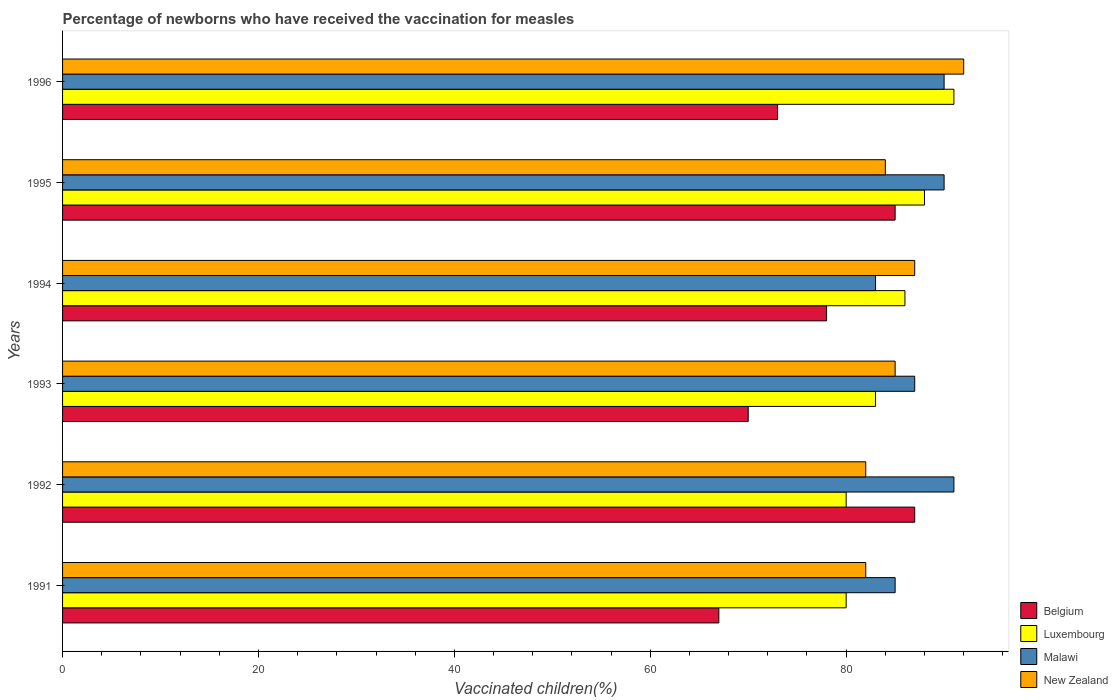How many different coloured bars are there?
Your response must be concise. 4. How many groups of bars are there?
Offer a terse response. 6. Are the number of bars on each tick of the Y-axis equal?
Ensure brevity in your answer.  Yes. How many bars are there on the 2nd tick from the top?
Ensure brevity in your answer.  4. How many bars are there on the 3rd tick from the bottom?
Provide a short and direct response. 4. What is the percentage of vaccinated children in New Zealand in 1991?
Provide a succinct answer. 82. Across all years, what is the maximum percentage of vaccinated children in Luxembourg?
Your answer should be compact. 91. Across all years, what is the minimum percentage of vaccinated children in New Zealand?
Ensure brevity in your answer.  82. In which year was the percentage of vaccinated children in Malawi maximum?
Offer a very short reply. 1992. What is the total percentage of vaccinated children in Luxembourg in the graph?
Provide a short and direct response. 508. What is the average percentage of vaccinated children in Belgium per year?
Provide a succinct answer. 76.67. In the year 1994, what is the difference between the percentage of vaccinated children in Belgium and percentage of vaccinated children in Luxembourg?
Provide a short and direct response. -8. What is the ratio of the percentage of vaccinated children in Luxembourg in 1992 to that in 1996?
Your answer should be compact. 0.88. What is the difference between the highest and the lowest percentage of vaccinated children in Malawi?
Provide a succinct answer. 8. What does the 4th bar from the bottom in 1995 represents?
Offer a terse response. New Zealand. How many bars are there?
Your answer should be very brief. 24. What is the difference between two consecutive major ticks on the X-axis?
Ensure brevity in your answer.  20. Does the graph contain grids?
Make the answer very short. No. Where does the legend appear in the graph?
Make the answer very short. Bottom right. How many legend labels are there?
Your answer should be compact. 4. How are the legend labels stacked?
Provide a short and direct response. Vertical. What is the title of the graph?
Make the answer very short. Percentage of newborns who have received the vaccination for measles. What is the label or title of the X-axis?
Offer a very short reply. Vaccinated children(%). What is the label or title of the Y-axis?
Ensure brevity in your answer.  Years. What is the Vaccinated children(%) in Belgium in 1991?
Make the answer very short. 67. What is the Vaccinated children(%) in Luxembourg in 1991?
Your answer should be very brief. 80. What is the Vaccinated children(%) in New Zealand in 1991?
Your answer should be very brief. 82. What is the Vaccinated children(%) in Belgium in 1992?
Make the answer very short. 87. What is the Vaccinated children(%) of Malawi in 1992?
Keep it short and to the point. 91. What is the Vaccinated children(%) of Belgium in 1993?
Provide a short and direct response. 70. What is the Vaccinated children(%) in Malawi in 1993?
Ensure brevity in your answer.  87. What is the Vaccinated children(%) in Belgium in 1995?
Your answer should be very brief. 85. What is the Vaccinated children(%) of New Zealand in 1995?
Your answer should be very brief. 84. What is the Vaccinated children(%) of Luxembourg in 1996?
Your answer should be compact. 91. What is the Vaccinated children(%) in Malawi in 1996?
Give a very brief answer. 90. What is the Vaccinated children(%) in New Zealand in 1996?
Ensure brevity in your answer.  92. Across all years, what is the maximum Vaccinated children(%) in Belgium?
Give a very brief answer. 87. Across all years, what is the maximum Vaccinated children(%) in Luxembourg?
Ensure brevity in your answer.  91. Across all years, what is the maximum Vaccinated children(%) of Malawi?
Offer a very short reply. 91. Across all years, what is the maximum Vaccinated children(%) in New Zealand?
Provide a short and direct response. 92. Across all years, what is the minimum Vaccinated children(%) in Belgium?
Offer a very short reply. 67. Across all years, what is the minimum Vaccinated children(%) in Luxembourg?
Offer a very short reply. 80. Across all years, what is the minimum Vaccinated children(%) of New Zealand?
Make the answer very short. 82. What is the total Vaccinated children(%) of Belgium in the graph?
Make the answer very short. 460. What is the total Vaccinated children(%) of Luxembourg in the graph?
Provide a short and direct response. 508. What is the total Vaccinated children(%) in Malawi in the graph?
Give a very brief answer. 526. What is the total Vaccinated children(%) of New Zealand in the graph?
Your answer should be very brief. 512. What is the difference between the Vaccinated children(%) of Belgium in 1991 and that in 1992?
Provide a succinct answer. -20. What is the difference between the Vaccinated children(%) of Malawi in 1991 and that in 1992?
Offer a terse response. -6. What is the difference between the Vaccinated children(%) of New Zealand in 1991 and that in 1992?
Your answer should be compact. 0. What is the difference between the Vaccinated children(%) of Belgium in 1991 and that in 1993?
Provide a succinct answer. -3. What is the difference between the Vaccinated children(%) of Malawi in 1991 and that in 1993?
Your answer should be compact. -2. What is the difference between the Vaccinated children(%) of Luxembourg in 1991 and that in 1994?
Provide a succinct answer. -6. What is the difference between the Vaccinated children(%) of Malawi in 1991 and that in 1994?
Your response must be concise. 2. What is the difference between the Vaccinated children(%) in New Zealand in 1991 and that in 1994?
Ensure brevity in your answer.  -5. What is the difference between the Vaccinated children(%) of Belgium in 1991 and that in 1995?
Ensure brevity in your answer.  -18. What is the difference between the Vaccinated children(%) in Luxembourg in 1991 and that in 1995?
Provide a short and direct response. -8. What is the difference between the Vaccinated children(%) in Malawi in 1991 and that in 1995?
Provide a short and direct response. -5. What is the difference between the Vaccinated children(%) in Belgium in 1991 and that in 1996?
Provide a short and direct response. -6. What is the difference between the Vaccinated children(%) in Malawi in 1991 and that in 1996?
Your answer should be compact. -5. What is the difference between the Vaccinated children(%) of Luxembourg in 1992 and that in 1994?
Keep it short and to the point. -6. What is the difference between the Vaccinated children(%) of Malawi in 1992 and that in 1994?
Ensure brevity in your answer.  8. What is the difference between the Vaccinated children(%) in Belgium in 1992 and that in 1995?
Your response must be concise. 2. What is the difference between the Vaccinated children(%) in Malawi in 1992 and that in 1996?
Provide a short and direct response. 1. What is the difference between the Vaccinated children(%) in New Zealand in 1992 and that in 1996?
Provide a short and direct response. -10. What is the difference between the Vaccinated children(%) of Luxembourg in 1993 and that in 1994?
Provide a succinct answer. -3. What is the difference between the Vaccinated children(%) of Malawi in 1993 and that in 1994?
Make the answer very short. 4. What is the difference between the Vaccinated children(%) in Belgium in 1993 and that in 1995?
Make the answer very short. -15. What is the difference between the Vaccinated children(%) of New Zealand in 1993 and that in 1995?
Offer a terse response. 1. What is the difference between the Vaccinated children(%) of Luxembourg in 1993 and that in 1996?
Give a very brief answer. -8. What is the difference between the Vaccinated children(%) of Malawi in 1993 and that in 1996?
Offer a very short reply. -3. What is the difference between the Vaccinated children(%) in Belgium in 1994 and that in 1996?
Make the answer very short. 5. What is the difference between the Vaccinated children(%) of Luxembourg in 1994 and that in 1996?
Offer a terse response. -5. What is the difference between the Vaccinated children(%) of Belgium in 1995 and that in 1996?
Make the answer very short. 12. What is the difference between the Vaccinated children(%) in Luxembourg in 1995 and that in 1996?
Your response must be concise. -3. What is the difference between the Vaccinated children(%) in Belgium in 1991 and the Vaccinated children(%) in Luxembourg in 1992?
Provide a succinct answer. -13. What is the difference between the Vaccinated children(%) in Belgium in 1991 and the Vaccinated children(%) in Malawi in 1992?
Offer a terse response. -24. What is the difference between the Vaccinated children(%) of Luxembourg in 1991 and the Vaccinated children(%) of Malawi in 1992?
Keep it short and to the point. -11. What is the difference between the Vaccinated children(%) of Luxembourg in 1991 and the Vaccinated children(%) of New Zealand in 1992?
Offer a terse response. -2. What is the difference between the Vaccinated children(%) in Belgium in 1991 and the Vaccinated children(%) in Malawi in 1993?
Give a very brief answer. -20. What is the difference between the Vaccinated children(%) of Belgium in 1991 and the Vaccinated children(%) of New Zealand in 1993?
Ensure brevity in your answer.  -18. What is the difference between the Vaccinated children(%) in Luxembourg in 1991 and the Vaccinated children(%) in Malawi in 1993?
Offer a very short reply. -7. What is the difference between the Vaccinated children(%) of Malawi in 1991 and the Vaccinated children(%) of New Zealand in 1993?
Ensure brevity in your answer.  0. What is the difference between the Vaccinated children(%) in Belgium in 1991 and the Vaccinated children(%) in Malawi in 1994?
Make the answer very short. -16. What is the difference between the Vaccinated children(%) of Belgium in 1991 and the Vaccinated children(%) of New Zealand in 1994?
Keep it short and to the point. -20. What is the difference between the Vaccinated children(%) in Malawi in 1991 and the Vaccinated children(%) in New Zealand in 1994?
Make the answer very short. -2. What is the difference between the Vaccinated children(%) of Belgium in 1991 and the Vaccinated children(%) of Luxembourg in 1995?
Give a very brief answer. -21. What is the difference between the Vaccinated children(%) of Luxembourg in 1991 and the Vaccinated children(%) of Malawi in 1995?
Offer a terse response. -10. What is the difference between the Vaccinated children(%) in Luxembourg in 1991 and the Vaccinated children(%) in New Zealand in 1995?
Your answer should be very brief. -4. What is the difference between the Vaccinated children(%) in Belgium in 1991 and the Vaccinated children(%) in Luxembourg in 1996?
Keep it short and to the point. -24. What is the difference between the Vaccinated children(%) of Belgium in 1991 and the Vaccinated children(%) of New Zealand in 1996?
Your answer should be compact. -25. What is the difference between the Vaccinated children(%) of Belgium in 1992 and the Vaccinated children(%) of New Zealand in 1993?
Offer a terse response. 2. What is the difference between the Vaccinated children(%) of Luxembourg in 1992 and the Vaccinated children(%) of Malawi in 1993?
Give a very brief answer. -7. What is the difference between the Vaccinated children(%) of Luxembourg in 1992 and the Vaccinated children(%) of New Zealand in 1993?
Give a very brief answer. -5. What is the difference between the Vaccinated children(%) of Malawi in 1992 and the Vaccinated children(%) of New Zealand in 1993?
Your answer should be very brief. 6. What is the difference between the Vaccinated children(%) in Luxembourg in 1992 and the Vaccinated children(%) in Malawi in 1994?
Offer a very short reply. -3. What is the difference between the Vaccinated children(%) in Malawi in 1992 and the Vaccinated children(%) in New Zealand in 1994?
Your response must be concise. 4. What is the difference between the Vaccinated children(%) in Belgium in 1992 and the Vaccinated children(%) in New Zealand in 1995?
Offer a very short reply. 3. What is the difference between the Vaccinated children(%) of Luxembourg in 1992 and the Vaccinated children(%) of New Zealand in 1995?
Provide a short and direct response. -4. What is the difference between the Vaccinated children(%) in Malawi in 1992 and the Vaccinated children(%) in New Zealand in 1995?
Offer a very short reply. 7. What is the difference between the Vaccinated children(%) of Belgium in 1992 and the Vaccinated children(%) of Malawi in 1996?
Ensure brevity in your answer.  -3. What is the difference between the Vaccinated children(%) in Belgium in 1992 and the Vaccinated children(%) in New Zealand in 1996?
Your response must be concise. -5. What is the difference between the Vaccinated children(%) of Luxembourg in 1992 and the Vaccinated children(%) of Malawi in 1996?
Give a very brief answer. -10. What is the difference between the Vaccinated children(%) in Luxembourg in 1992 and the Vaccinated children(%) in New Zealand in 1996?
Your answer should be compact. -12. What is the difference between the Vaccinated children(%) of Malawi in 1992 and the Vaccinated children(%) of New Zealand in 1996?
Offer a very short reply. -1. What is the difference between the Vaccinated children(%) of Belgium in 1993 and the Vaccinated children(%) of Malawi in 1994?
Offer a terse response. -13. What is the difference between the Vaccinated children(%) of Malawi in 1993 and the Vaccinated children(%) of New Zealand in 1994?
Give a very brief answer. 0. What is the difference between the Vaccinated children(%) in Belgium in 1993 and the Vaccinated children(%) in Luxembourg in 1995?
Keep it short and to the point. -18. What is the difference between the Vaccinated children(%) in Belgium in 1993 and the Vaccinated children(%) in New Zealand in 1995?
Provide a short and direct response. -14. What is the difference between the Vaccinated children(%) in Malawi in 1993 and the Vaccinated children(%) in New Zealand in 1995?
Provide a succinct answer. 3. What is the difference between the Vaccinated children(%) in Belgium in 1993 and the Vaccinated children(%) in Luxembourg in 1996?
Provide a succinct answer. -21. What is the difference between the Vaccinated children(%) in Luxembourg in 1993 and the Vaccinated children(%) in Malawi in 1996?
Keep it short and to the point. -7. What is the difference between the Vaccinated children(%) of Luxembourg in 1993 and the Vaccinated children(%) of New Zealand in 1996?
Offer a very short reply. -9. What is the difference between the Vaccinated children(%) in Malawi in 1993 and the Vaccinated children(%) in New Zealand in 1996?
Provide a succinct answer. -5. What is the difference between the Vaccinated children(%) in Belgium in 1994 and the Vaccinated children(%) in Luxembourg in 1995?
Give a very brief answer. -10. What is the difference between the Vaccinated children(%) in Luxembourg in 1994 and the Vaccinated children(%) in Malawi in 1995?
Offer a very short reply. -4. What is the difference between the Vaccinated children(%) of Luxembourg in 1994 and the Vaccinated children(%) of New Zealand in 1995?
Provide a short and direct response. 2. What is the difference between the Vaccinated children(%) of Malawi in 1994 and the Vaccinated children(%) of New Zealand in 1995?
Offer a terse response. -1. What is the difference between the Vaccinated children(%) of Belgium in 1994 and the Vaccinated children(%) of Malawi in 1996?
Give a very brief answer. -12. What is the difference between the Vaccinated children(%) of Belgium in 1994 and the Vaccinated children(%) of New Zealand in 1996?
Your response must be concise. -14. What is the difference between the Vaccinated children(%) in Luxembourg in 1994 and the Vaccinated children(%) in Malawi in 1996?
Your response must be concise. -4. What is the difference between the Vaccinated children(%) in Belgium in 1995 and the Vaccinated children(%) in Luxembourg in 1996?
Make the answer very short. -6. What is the difference between the Vaccinated children(%) in Belgium in 1995 and the Vaccinated children(%) in New Zealand in 1996?
Offer a very short reply. -7. What is the average Vaccinated children(%) of Belgium per year?
Provide a succinct answer. 76.67. What is the average Vaccinated children(%) of Luxembourg per year?
Your answer should be compact. 84.67. What is the average Vaccinated children(%) in Malawi per year?
Your response must be concise. 87.67. What is the average Vaccinated children(%) of New Zealand per year?
Give a very brief answer. 85.33. In the year 1991, what is the difference between the Vaccinated children(%) of Belgium and Vaccinated children(%) of Luxembourg?
Your answer should be compact. -13. In the year 1991, what is the difference between the Vaccinated children(%) of Luxembourg and Vaccinated children(%) of Malawi?
Your answer should be compact. -5. In the year 1991, what is the difference between the Vaccinated children(%) of Luxembourg and Vaccinated children(%) of New Zealand?
Your answer should be very brief. -2. In the year 1991, what is the difference between the Vaccinated children(%) in Malawi and Vaccinated children(%) in New Zealand?
Keep it short and to the point. 3. In the year 1992, what is the difference between the Vaccinated children(%) of Belgium and Vaccinated children(%) of Malawi?
Your answer should be compact. -4. In the year 1992, what is the difference between the Vaccinated children(%) of Belgium and Vaccinated children(%) of New Zealand?
Your answer should be compact. 5. In the year 1992, what is the difference between the Vaccinated children(%) of Luxembourg and Vaccinated children(%) of Malawi?
Provide a short and direct response. -11. In the year 1992, what is the difference between the Vaccinated children(%) in Luxembourg and Vaccinated children(%) in New Zealand?
Provide a short and direct response. -2. In the year 1992, what is the difference between the Vaccinated children(%) of Malawi and Vaccinated children(%) of New Zealand?
Offer a terse response. 9. In the year 1993, what is the difference between the Vaccinated children(%) of Belgium and Vaccinated children(%) of New Zealand?
Provide a short and direct response. -15. In the year 1993, what is the difference between the Vaccinated children(%) of Luxembourg and Vaccinated children(%) of New Zealand?
Give a very brief answer. -2. In the year 1994, what is the difference between the Vaccinated children(%) of Luxembourg and Vaccinated children(%) of Malawi?
Your answer should be compact. 3. In the year 1994, what is the difference between the Vaccinated children(%) of Luxembourg and Vaccinated children(%) of New Zealand?
Make the answer very short. -1. In the year 1995, what is the difference between the Vaccinated children(%) of Belgium and Vaccinated children(%) of Luxembourg?
Offer a very short reply. -3. In the year 1995, what is the difference between the Vaccinated children(%) in Belgium and Vaccinated children(%) in New Zealand?
Offer a terse response. 1. In the year 1995, what is the difference between the Vaccinated children(%) of Luxembourg and Vaccinated children(%) of Malawi?
Provide a short and direct response. -2. In the year 1995, what is the difference between the Vaccinated children(%) in Malawi and Vaccinated children(%) in New Zealand?
Give a very brief answer. 6. In the year 1996, what is the difference between the Vaccinated children(%) of Belgium and Vaccinated children(%) of Malawi?
Provide a succinct answer. -17. In the year 1996, what is the difference between the Vaccinated children(%) in Belgium and Vaccinated children(%) in New Zealand?
Make the answer very short. -19. In the year 1996, what is the difference between the Vaccinated children(%) in Luxembourg and Vaccinated children(%) in Malawi?
Give a very brief answer. 1. In the year 1996, what is the difference between the Vaccinated children(%) in Malawi and Vaccinated children(%) in New Zealand?
Keep it short and to the point. -2. What is the ratio of the Vaccinated children(%) of Belgium in 1991 to that in 1992?
Offer a very short reply. 0.77. What is the ratio of the Vaccinated children(%) of Malawi in 1991 to that in 1992?
Give a very brief answer. 0.93. What is the ratio of the Vaccinated children(%) of New Zealand in 1991 to that in 1992?
Give a very brief answer. 1. What is the ratio of the Vaccinated children(%) in Belgium in 1991 to that in 1993?
Keep it short and to the point. 0.96. What is the ratio of the Vaccinated children(%) in Luxembourg in 1991 to that in 1993?
Give a very brief answer. 0.96. What is the ratio of the Vaccinated children(%) of Malawi in 1991 to that in 1993?
Your answer should be very brief. 0.98. What is the ratio of the Vaccinated children(%) of New Zealand in 1991 to that in 1993?
Your response must be concise. 0.96. What is the ratio of the Vaccinated children(%) of Belgium in 1991 to that in 1994?
Your answer should be compact. 0.86. What is the ratio of the Vaccinated children(%) in Luxembourg in 1991 to that in 1994?
Your answer should be very brief. 0.93. What is the ratio of the Vaccinated children(%) in Malawi in 1991 to that in 1994?
Offer a terse response. 1.02. What is the ratio of the Vaccinated children(%) in New Zealand in 1991 to that in 1994?
Keep it short and to the point. 0.94. What is the ratio of the Vaccinated children(%) of Belgium in 1991 to that in 1995?
Provide a short and direct response. 0.79. What is the ratio of the Vaccinated children(%) in Malawi in 1991 to that in 1995?
Offer a very short reply. 0.94. What is the ratio of the Vaccinated children(%) in New Zealand in 1991 to that in 1995?
Provide a short and direct response. 0.98. What is the ratio of the Vaccinated children(%) in Belgium in 1991 to that in 1996?
Offer a very short reply. 0.92. What is the ratio of the Vaccinated children(%) in Luxembourg in 1991 to that in 1996?
Ensure brevity in your answer.  0.88. What is the ratio of the Vaccinated children(%) in Malawi in 1991 to that in 1996?
Offer a very short reply. 0.94. What is the ratio of the Vaccinated children(%) in New Zealand in 1991 to that in 1996?
Your answer should be compact. 0.89. What is the ratio of the Vaccinated children(%) in Belgium in 1992 to that in 1993?
Offer a terse response. 1.24. What is the ratio of the Vaccinated children(%) of Luxembourg in 1992 to that in 1993?
Your response must be concise. 0.96. What is the ratio of the Vaccinated children(%) in Malawi in 1992 to that in 1993?
Give a very brief answer. 1.05. What is the ratio of the Vaccinated children(%) of New Zealand in 1992 to that in 1993?
Offer a terse response. 0.96. What is the ratio of the Vaccinated children(%) in Belgium in 1992 to that in 1994?
Provide a succinct answer. 1.12. What is the ratio of the Vaccinated children(%) in Luxembourg in 1992 to that in 1994?
Give a very brief answer. 0.93. What is the ratio of the Vaccinated children(%) in Malawi in 1992 to that in 1994?
Your answer should be compact. 1.1. What is the ratio of the Vaccinated children(%) of New Zealand in 1992 to that in 1994?
Offer a terse response. 0.94. What is the ratio of the Vaccinated children(%) in Belgium in 1992 to that in 1995?
Give a very brief answer. 1.02. What is the ratio of the Vaccinated children(%) in Malawi in 1992 to that in 1995?
Make the answer very short. 1.01. What is the ratio of the Vaccinated children(%) of New Zealand in 1992 to that in 1995?
Make the answer very short. 0.98. What is the ratio of the Vaccinated children(%) of Belgium in 1992 to that in 1996?
Your answer should be compact. 1.19. What is the ratio of the Vaccinated children(%) of Luxembourg in 1992 to that in 1996?
Your answer should be very brief. 0.88. What is the ratio of the Vaccinated children(%) of Malawi in 1992 to that in 1996?
Your answer should be compact. 1.01. What is the ratio of the Vaccinated children(%) of New Zealand in 1992 to that in 1996?
Keep it short and to the point. 0.89. What is the ratio of the Vaccinated children(%) in Belgium in 1993 to that in 1994?
Offer a terse response. 0.9. What is the ratio of the Vaccinated children(%) of Luxembourg in 1993 to that in 1994?
Your answer should be compact. 0.97. What is the ratio of the Vaccinated children(%) in Malawi in 1993 to that in 1994?
Your answer should be very brief. 1.05. What is the ratio of the Vaccinated children(%) of Belgium in 1993 to that in 1995?
Your response must be concise. 0.82. What is the ratio of the Vaccinated children(%) in Luxembourg in 1993 to that in 1995?
Give a very brief answer. 0.94. What is the ratio of the Vaccinated children(%) in Malawi in 1993 to that in 1995?
Your answer should be compact. 0.97. What is the ratio of the Vaccinated children(%) of New Zealand in 1993 to that in 1995?
Provide a succinct answer. 1.01. What is the ratio of the Vaccinated children(%) in Belgium in 1993 to that in 1996?
Your answer should be compact. 0.96. What is the ratio of the Vaccinated children(%) of Luxembourg in 1993 to that in 1996?
Give a very brief answer. 0.91. What is the ratio of the Vaccinated children(%) of Malawi in 1993 to that in 1996?
Ensure brevity in your answer.  0.97. What is the ratio of the Vaccinated children(%) of New Zealand in 1993 to that in 1996?
Ensure brevity in your answer.  0.92. What is the ratio of the Vaccinated children(%) in Belgium in 1994 to that in 1995?
Offer a terse response. 0.92. What is the ratio of the Vaccinated children(%) of Luxembourg in 1994 to that in 1995?
Your response must be concise. 0.98. What is the ratio of the Vaccinated children(%) of Malawi in 1994 to that in 1995?
Offer a terse response. 0.92. What is the ratio of the Vaccinated children(%) in New Zealand in 1994 to that in 1995?
Provide a short and direct response. 1.04. What is the ratio of the Vaccinated children(%) in Belgium in 1994 to that in 1996?
Offer a very short reply. 1.07. What is the ratio of the Vaccinated children(%) in Luxembourg in 1994 to that in 1996?
Provide a succinct answer. 0.95. What is the ratio of the Vaccinated children(%) of Malawi in 1994 to that in 1996?
Your answer should be very brief. 0.92. What is the ratio of the Vaccinated children(%) of New Zealand in 1994 to that in 1996?
Keep it short and to the point. 0.95. What is the ratio of the Vaccinated children(%) of Belgium in 1995 to that in 1996?
Provide a succinct answer. 1.16. What is the ratio of the Vaccinated children(%) in Malawi in 1995 to that in 1996?
Keep it short and to the point. 1. What is the ratio of the Vaccinated children(%) in New Zealand in 1995 to that in 1996?
Your response must be concise. 0.91. What is the difference between the highest and the second highest Vaccinated children(%) of Belgium?
Offer a very short reply. 2. What is the difference between the highest and the second highest Vaccinated children(%) of Luxembourg?
Give a very brief answer. 3. What is the difference between the highest and the second highest Vaccinated children(%) in Malawi?
Offer a terse response. 1. 